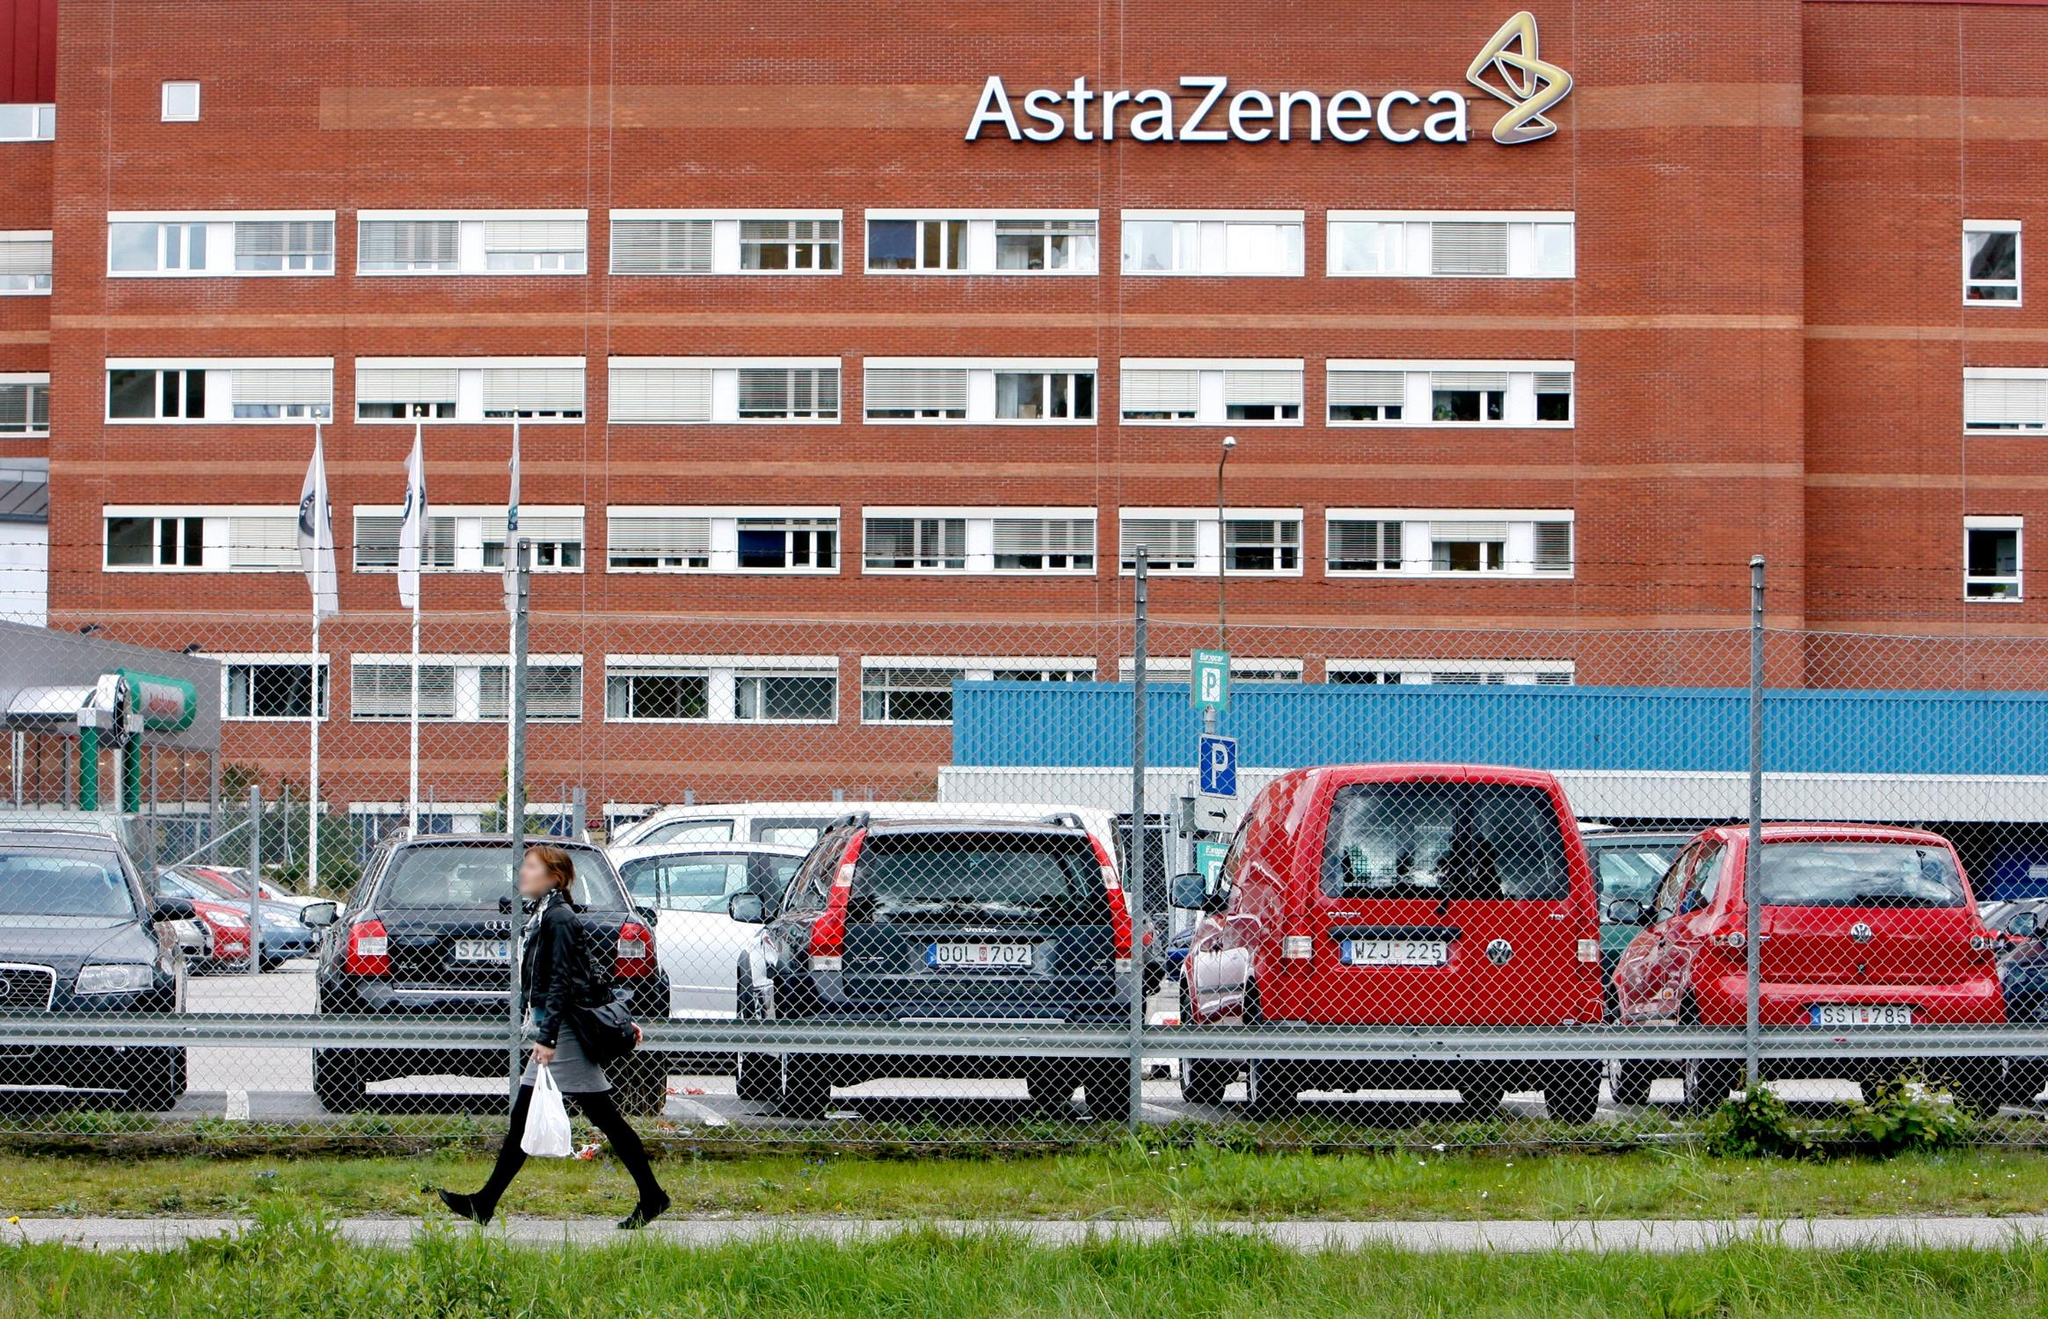Can you write a short story based on the scene depicted in the image? On a dreary Thursday morning, Anna hurried across the parking lot of the AstraZeneca building, clutching a bag of takeout lunch. The overcast sky mirrored her on-the-go thoughts, filled with deadlines and critical meetings. She had been working on a promising new drug, a groundbreaking treatment that could change countless lives. As she walked swiftly, Anna glanced at the familiar red brick facade that had become her second home. Inside those walls, dreams of medical advancements were crafted, reviewed, and sometimes even crushed. But today, hope simmered in the labs. Today could be the day they cracked the final formula, she thought, quickening her pace. The building, a silent spectator to her daily grind, stood as a fortress of innovation, housing the hopes and anxieties of those who worked within it.  Imagine a futuristic scenario where this building is repurposed. What might it become and how would it look? Years into the future, the AstraZeneca building, once a nucleus of pharmaceutical innovation, has been transformed into a cutting-edge bioengineering hub focusing on creating synthetic body parts. The red brick exterior remains, a nostalgic nod to its illustrious past, but now it’s interspersed with sleek, transparent panels that allow views into the high-tech laboratories. Inside, robotic assistants and AI-driven diagnostics tools fill the space, helping scientists push the limits of bioengineering. The parking lot has been converted into a lush garden with bioluminescent plants that light up the night, creating a serene environment for the employees. Drones buzz overhead, delivering supplies, and the logo on the building now glows with a modern, dynamic light display, symbolizing not just a commitment to global health, but also to futuristic innovation. 